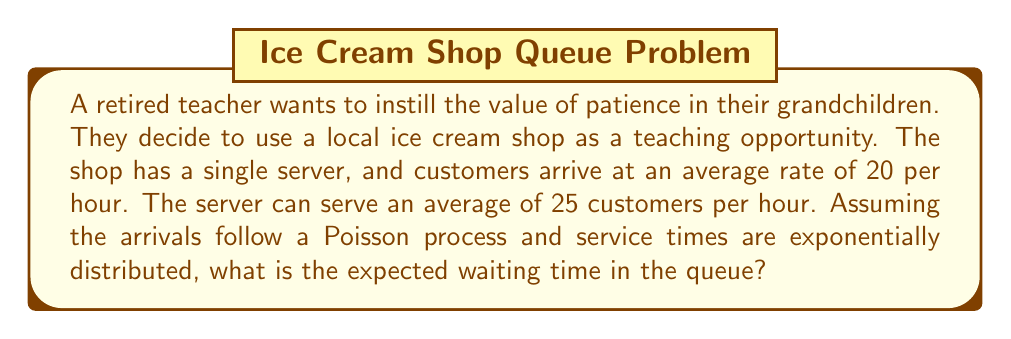Teach me how to tackle this problem. Let's approach this step-by-step using M/M/1 queueing theory:

1) First, we need to identify our parameters:
   $\lambda$ = arrival rate = 20 customers/hour
   $\mu$ = service rate = 25 customers/hour

2) Calculate the utilization factor $\rho$:
   $$\rho = \frac{\lambda}{\mu} = \frac{20}{25} = 0.8$$

3) The expected number of customers in the queue ($L_q$) for an M/M/1 system is given by:
   $$L_q = \frac{\rho^2}{1-\rho} = \frac{0.8^2}{1-0.8} = \frac{0.64}{0.2} = 3.2$$

4) Using Little's Law, we can find the expected waiting time in the queue ($W_q$):
   $$W_q = \frac{L_q}{\lambda}$$

5) Substituting our values:
   $$W_q = \frac{3.2}{20} = 0.16 \text{ hours}$$

6) Convert to minutes:
   $$0.16 \text{ hours} \times 60 \text{ minutes/hour} = 9.6 \text{ minutes}$$

Therefore, the expected waiting time in the queue is 9.6 minutes.
Answer: 9.6 minutes 